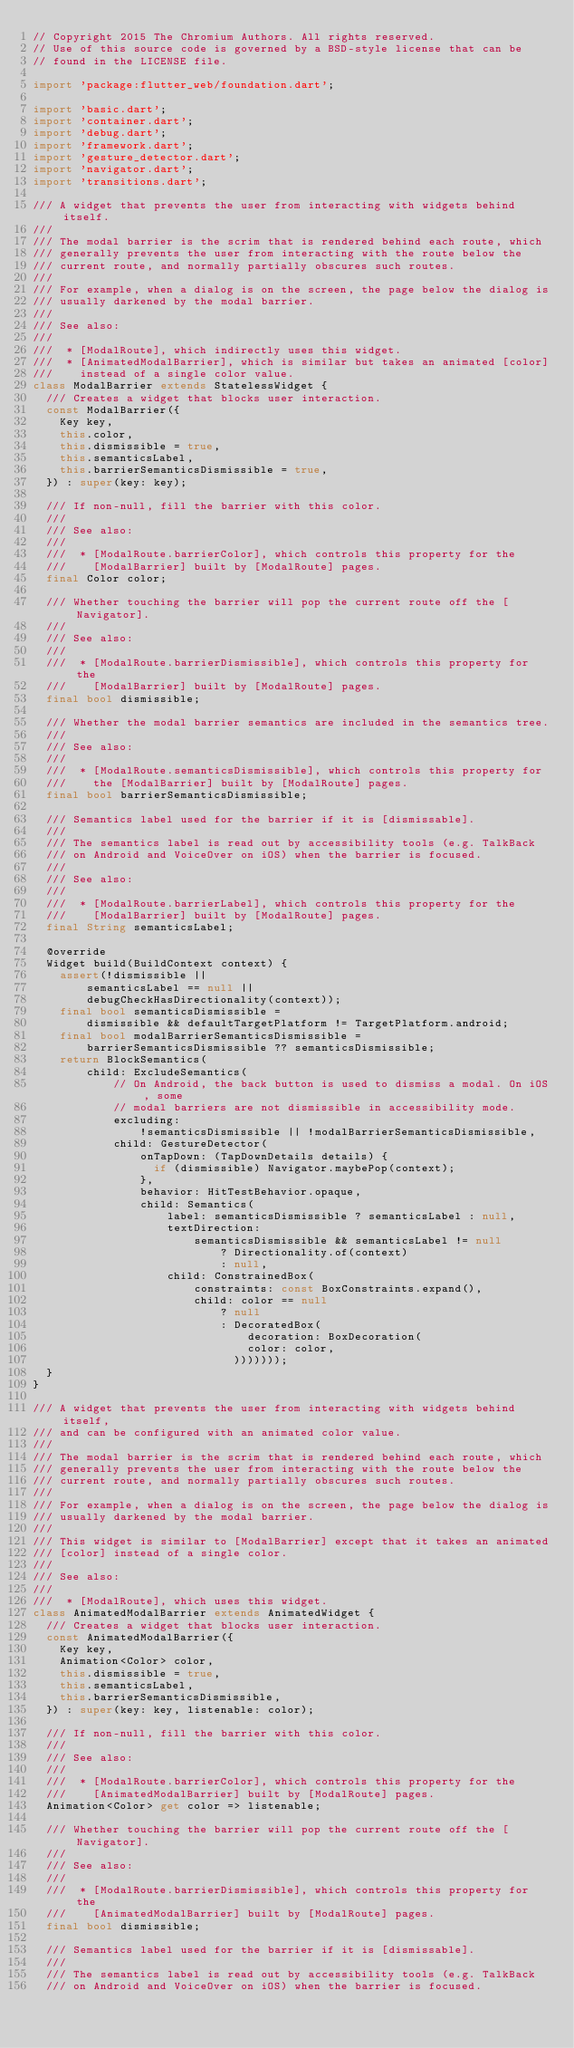<code> <loc_0><loc_0><loc_500><loc_500><_Dart_>// Copyright 2015 The Chromium Authors. All rights reserved.
// Use of this source code is governed by a BSD-style license that can be
// found in the LICENSE file.

import 'package:flutter_web/foundation.dart';

import 'basic.dart';
import 'container.dart';
import 'debug.dart';
import 'framework.dart';
import 'gesture_detector.dart';
import 'navigator.dart';
import 'transitions.dart';

/// A widget that prevents the user from interacting with widgets behind itself.
///
/// The modal barrier is the scrim that is rendered behind each route, which
/// generally prevents the user from interacting with the route below the
/// current route, and normally partially obscures such routes.
///
/// For example, when a dialog is on the screen, the page below the dialog is
/// usually darkened by the modal barrier.
///
/// See also:
///
///  * [ModalRoute], which indirectly uses this widget.
///  * [AnimatedModalBarrier], which is similar but takes an animated [color]
///    instead of a single color value.
class ModalBarrier extends StatelessWidget {
  /// Creates a widget that blocks user interaction.
  const ModalBarrier({
    Key key,
    this.color,
    this.dismissible = true,
    this.semanticsLabel,
    this.barrierSemanticsDismissible = true,
  }) : super(key: key);

  /// If non-null, fill the barrier with this color.
  ///
  /// See also:
  ///
  ///  * [ModalRoute.barrierColor], which controls this property for the
  ///    [ModalBarrier] built by [ModalRoute] pages.
  final Color color;

  /// Whether touching the barrier will pop the current route off the [Navigator].
  ///
  /// See also:
  ///
  ///  * [ModalRoute.barrierDismissible], which controls this property for the
  ///    [ModalBarrier] built by [ModalRoute] pages.
  final bool dismissible;

  /// Whether the modal barrier semantics are included in the semantics tree.
  ///
  /// See also:
  ///
  ///  * [ModalRoute.semanticsDismissible], which controls this property for
  ///    the [ModalBarrier] built by [ModalRoute] pages.
  final bool barrierSemanticsDismissible;

  /// Semantics label used for the barrier if it is [dismissable].
  ///
  /// The semantics label is read out by accessibility tools (e.g. TalkBack
  /// on Android and VoiceOver on iOS) when the barrier is focused.
  ///
  /// See also:
  ///
  ///  * [ModalRoute.barrierLabel], which controls this property for the
  ///    [ModalBarrier] built by [ModalRoute] pages.
  final String semanticsLabel;

  @override
  Widget build(BuildContext context) {
    assert(!dismissible ||
        semanticsLabel == null ||
        debugCheckHasDirectionality(context));
    final bool semanticsDismissible =
        dismissible && defaultTargetPlatform != TargetPlatform.android;
    final bool modalBarrierSemanticsDismissible =
        barrierSemanticsDismissible ?? semanticsDismissible;
    return BlockSemantics(
        child: ExcludeSemantics(
            // On Android, the back button is used to dismiss a modal. On iOS, some
            // modal barriers are not dismissible in accessibility mode.
            excluding:
                !semanticsDismissible || !modalBarrierSemanticsDismissible,
            child: GestureDetector(
                onTapDown: (TapDownDetails details) {
                  if (dismissible) Navigator.maybePop(context);
                },
                behavior: HitTestBehavior.opaque,
                child: Semantics(
                    label: semanticsDismissible ? semanticsLabel : null,
                    textDirection:
                        semanticsDismissible && semanticsLabel != null
                            ? Directionality.of(context)
                            : null,
                    child: ConstrainedBox(
                        constraints: const BoxConstraints.expand(),
                        child: color == null
                            ? null
                            : DecoratedBox(
                                decoration: BoxDecoration(
                                color: color,
                              )))))));
  }
}

/// A widget that prevents the user from interacting with widgets behind itself,
/// and can be configured with an animated color value.
///
/// The modal barrier is the scrim that is rendered behind each route, which
/// generally prevents the user from interacting with the route below the
/// current route, and normally partially obscures such routes.
///
/// For example, when a dialog is on the screen, the page below the dialog is
/// usually darkened by the modal barrier.
///
/// This widget is similar to [ModalBarrier] except that it takes an animated
/// [color] instead of a single color.
///
/// See also:
///
///  * [ModalRoute], which uses this widget.
class AnimatedModalBarrier extends AnimatedWidget {
  /// Creates a widget that blocks user interaction.
  const AnimatedModalBarrier({
    Key key,
    Animation<Color> color,
    this.dismissible = true,
    this.semanticsLabel,
    this.barrierSemanticsDismissible,
  }) : super(key: key, listenable: color);

  /// If non-null, fill the barrier with this color.
  ///
  /// See also:
  ///
  ///  * [ModalRoute.barrierColor], which controls this property for the
  ///    [AnimatedModalBarrier] built by [ModalRoute] pages.
  Animation<Color> get color => listenable;

  /// Whether touching the barrier will pop the current route off the [Navigator].
  ///
  /// See also:
  ///
  ///  * [ModalRoute.barrierDismissible], which controls this property for the
  ///    [AnimatedModalBarrier] built by [ModalRoute] pages.
  final bool dismissible;

  /// Semantics label used for the barrier if it is [dismissable].
  ///
  /// The semantics label is read out by accessibility tools (e.g. TalkBack
  /// on Android and VoiceOver on iOS) when the barrier is focused.</code> 